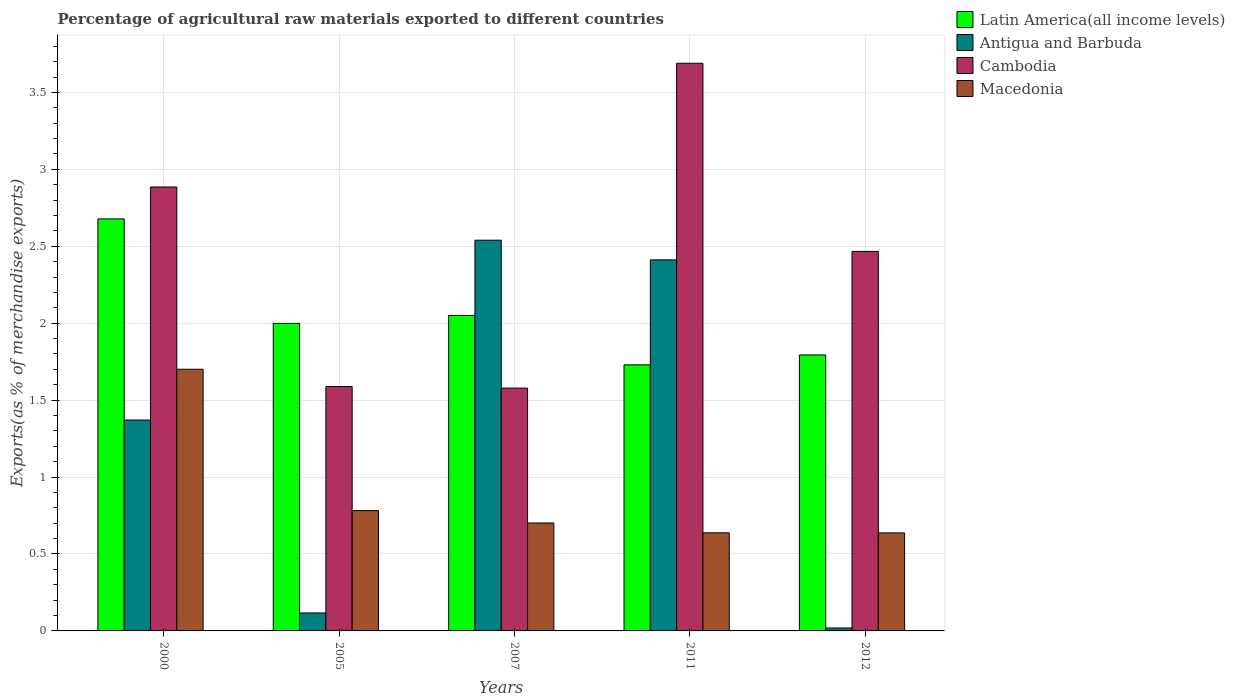How many different coloured bars are there?
Provide a succinct answer. 4. How many groups of bars are there?
Give a very brief answer. 5. Are the number of bars on each tick of the X-axis equal?
Offer a very short reply. Yes. How many bars are there on the 3rd tick from the right?
Ensure brevity in your answer.  4. What is the label of the 2nd group of bars from the left?
Ensure brevity in your answer.  2005. What is the percentage of exports to different countries in Antigua and Barbuda in 2000?
Your response must be concise. 1.37. Across all years, what is the maximum percentage of exports to different countries in Cambodia?
Make the answer very short. 3.69. Across all years, what is the minimum percentage of exports to different countries in Antigua and Barbuda?
Offer a terse response. 0.02. In which year was the percentage of exports to different countries in Macedonia minimum?
Offer a very short reply. 2012. What is the total percentage of exports to different countries in Latin America(all income levels) in the graph?
Your answer should be very brief. 10.25. What is the difference between the percentage of exports to different countries in Antigua and Barbuda in 2000 and that in 2007?
Ensure brevity in your answer.  -1.17. What is the difference between the percentage of exports to different countries in Cambodia in 2011 and the percentage of exports to different countries in Macedonia in 2000?
Offer a terse response. 1.99. What is the average percentage of exports to different countries in Cambodia per year?
Make the answer very short. 2.44. In the year 2005, what is the difference between the percentage of exports to different countries in Latin America(all income levels) and percentage of exports to different countries in Cambodia?
Make the answer very short. 0.41. What is the ratio of the percentage of exports to different countries in Antigua and Barbuda in 2007 to that in 2012?
Your response must be concise. 132.37. Is the difference between the percentage of exports to different countries in Latin America(all income levels) in 2000 and 2012 greater than the difference between the percentage of exports to different countries in Cambodia in 2000 and 2012?
Offer a very short reply. Yes. What is the difference between the highest and the second highest percentage of exports to different countries in Cambodia?
Offer a very short reply. 0.8. What is the difference between the highest and the lowest percentage of exports to different countries in Antigua and Barbuda?
Offer a terse response. 2.52. Is the sum of the percentage of exports to different countries in Antigua and Barbuda in 2005 and 2012 greater than the maximum percentage of exports to different countries in Latin America(all income levels) across all years?
Make the answer very short. No. Is it the case that in every year, the sum of the percentage of exports to different countries in Cambodia and percentage of exports to different countries in Macedonia is greater than the sum of percentage of exports to different countries in Antigua and Barbuda and percentage of exports to different countries in Latin America(all income levels)?
Give a very brief answer. No. What does the 3rd bar from the left in 2000 represents?
Give a very brief answer. Cambodia. What does the 3rd bar from the right in 2000 represents?
Give a very brief answer. Antigua and Barbuda. How many years are there in the graph?
Ensure brevity in your answer.  5. What is the difference between two consecutive major ticks on the Y-axis?
Your answer should be compact. 0.5. Are the values on the major ticks of Y-axis written in scientific E-notation?
Your response must be concise. No. Does the graph contain any zero values?
Provide a short and direct response. No. Does the graph contain grids?
Provide a short and direct response. Yes. What is the title of the graph?
Make the answer very short. Percentage of agricultural raw materials exported to different countries. What is the label or title of the X-axis?
Keep it short and to the point. Years. What is the label or title of the Y-axis?
Offer a terse response. Exports(as % of merchandise exports). What is the Exports(as % of merchandise exports) in Latin America(all income levels) in 2000?
Offer a very short reply. 2.68. What is the Exports(as % of merchandise exports) in Antigua and Barbuda in 2000?
Provide a succinct answer. 1.37. What is the Exports(as % of merchandise exports) in Cambodia in 2000?
Provide a short and direct response. 2.89. What is the Exports(as % of merchandise exports) of Macedonia in 2000?
Your answer should be compact. 1.7. What is the Exports(as % of merchandise exports) in Latin America(all income levels) in 2005?
Make the answer very short. 2. What is the Exports(as % of merchandise exports) in Antigua and Barbuda in 2005?
Offer a very short reply. 0.12. What is the Exports(as % of merchandise exports) in Cambodia in 2005?
Keep it short and to the point. 1.59. What is the Exports(as % of merchandise exports) in Macedonia in 2005?
Your answer should be compact. 0.78. What is the Exports(as % of merchandise exports) in Latin America(all income levels) in 2007?
Offer a terse response. 2.05. What is the Exports(as % of merchandise exports) of Antigua and Barbuda in 2007?
Offer a terse response. 2.54. What is the Exports(as % of merchandise exports) in Cambodia in 2007?
Provide a short and direct response. 1.58. What is the Exports(as % of merchandise exports) of Macedonia in 2007?
Give a very brief answer. 0.7. What is the Exports(as % of merchandise exports) of Latin America(all income levels) in 2011?
Give a very brief answer. 1.73. What is the Exports(as % of merchandise exports) in Antigua and Barbuda in 2011?
Your answer should be compact. 2.41. What is the Exports(as % of merchandise exports) of Cambodia in 2011?
Provide a short and direct response. 3.69. What is the Exports(as % of merchandise exports) of Macedonia in 2011?
Keep it short and to the point. 0.64. What is the Exports(as % of merchandise exports) in Latin America(all income levels) in 2012?
Keep it short and to the point. 1.79. What is the Exports(as % of merchandise exports) of Antigua and Barbuda in 2012?
Your response must be concise. 0.02. What is the Exports(as % of merchandise exports) of Cambodia in 2012?
Your response must be concise. 2.47. What is the Exports(as % of merchandise exports) of Macedonia in 2012?
Provide a short and direct response. 0.64. Across all years, what is the maximum Exports(as % of merchandise exports) of Latin America(all income levels)?
Ensure brevity in your answer.  2.68. Across all years, what is the maximum Exports(as % of merchandise exports) in Antigua and Barbuda?
Give a very brief answer. 2.54. Across all years, what is the maximum Exports(as % of merchandise exports) of Cambodia?
Offer a terse response. 3.69. Across all years, what is the maximum Exports(as % of merchandise exports) of Macedonia?
Give a very brief answer. 1.7. Across all years, what is the minimum Exports(as % of merchandise exports) of Latin America(all income levels)?
Keep it short and to the point. 1.73. Across all years, what is the minimum Exports(as % of merchandise exports) in Antigua and Barbuda?
Ensure brevity in your answer.  0.02. Across all years, what is the minimum Exports(as % of merchandise exports) of Cambodia?
Your answer should be very brief. 1.58. Across all years, what is the minimum Exports(as % of merchandise exports) of Macedonia?
Ensure brevity in your answer.  0.64. What is the total Exports(as % of merchandise exports) in Latin America(all income levels) in the graph?
Ensure brevity in your answer.  10.25. What is the total Exports(as % of merchandise exports) of Antigua and Barbuda in the graph?
Give a very brief answer. 6.46. What is the total Exports(as % of merchandise exports) of Cambodia in the graph?
Provide a succinct answer. 12.21. What is the total Exports(as % of merchandise exports) of Macedonia in the graph?
Offer a very short reply. 4.46. What is the difference between the Exports(as % of merchandise exports) in Latin America(all income levels) in 2000 and that in 2005?
Offer a terse response. 0.68. What is the difference between the Exports(as % of merchandise exports) of Antigua and Barbuda in 2000 and that in 2005?
Provide a succinct answer. 1.25. What is the difference between the Exports(as % of merchandise exports) of Cambodia in 2000 and that in 2005?
Your response must be concise. 1.3. What is the difference between the Exports(as % of merchandise exports) of Macedonia in 2000 and that in 2005?
Ensure brevity in your answer.  0.92. What is the difference between the Exports(as % of merchandise exports) in Latin America(all income levels) in 2000 and that in 2007?
Keep it short and to the point. 0.63. What is the difference between the Exports(as % of merchandise exports) of Antigua and Barbuda in 2000 and that in 2007?
Give a very brief answer. -1.17. What is the difference between the Exports(as % of merchandise exports) of Cambodia in 2000 and that in 2007?
Make the answer very short. 1.31. What is the difference between the Exports(as % of merchandise exports) of Macedonia in 2000 and that in 2007?
Offer a very short reply. 1. What is the difference between the Exports(as % of merchandise exports) of Latin America(all income levels) in 2000 and that in 2011?
Make the answer very short. 0.95. What is the difference between the Exports(as % of merchandise exports) in Antigua and Barbuda in 2000 and that in 2011?
Give a very brief answer. -1.04. What is the difference between the Exports(as % of merchandise exports) in Cambodia in 2000 and that in 2011?
Offer a terse response. -0.8. What is the difference between the Exports(as % of merchandise exports) in Macedonia in 2000 and that in 2011?
Your answer should be very brief. 1.06. What is the difference between the Exports(as % of merchandise exports) of Latin America(all income levels) in 2000 and that in 2012?
Your response must be concise. 0.88. What is the difference between the Exports(as % of merchandise exports) of Antigua and Barbuda in 2000 and that in 2012?
Provide a succinct answer. 1.35. What is the difference between the Exports(as % of merchandise exports) of Cambodia in 2000 and that in 2012?
Provide a succinct answer. 0.42. What is the difference between the Exports(as % of merchandise exports) of Macedonia in 2000 and that in 2012?
Keep it short and to the point. 1.06. What is the difference between the Exports(as % of merchandise exports) in Latin America(all income levels) in 2005 and that in 2007?
Your answer should be very brief. -0.05. What is the difference between the Exports(as % of merchandise exports) in Antigua and Barbuda in 2005 and that in 2007?
Provide a short and direct response. -2.42. What is the difference between the Exports(as % of merchandise exports) in Cambodia in 2005 and that in 2007?
Offer a very short reply. 0.01. What is the difference between the Exports(as % of merchandise exports) of Macedonia in 2005 and that in 2007?
Ensure brevity in your answer.  0.08. What is the difference between the Exports(as % of merchandise exports) in Latin America(all income levels) in 2005 and that in 2011?
Ensure brevity in your answer.  0.27. What is the difference between the Exports(as % of merchandise exports) of Antigua and Barbuda in 2005 and that in 2011?
Provide a short and direct response. -2.29. What is the difference between the Exports(as % of merchandise exports) in Cambodia in 2005 and that in 2011?
Make the answer very short. -2.1. What is the difference between the Exports(as % of merchandise exports) of Macedonia in 2005 and that in 2011?
Make the answer very short. 0.14. What is the difference between the Exports(as % of merchandise exports) of Latin America(all income levels) in 2005 and that in 2012?
Provide a short and direct response. 0.2. What is the difference between the Exports(as % of merchandise exports) of Antigua and Barbuda in 2005 and that in 2012?
Provide a short and direct response. 0.1. What is the difference between the Exports(as % of merchandise exports) in Cambodia in 2005 and that in 2012?
Ensure brevity in your answer.  -0.88. What is the difference between the Exports(as % of merchandise exports) of Macedonia in 2005 and that in 2012?
Provide a short and direct response. 0.14. What is the difference between the Exports(as % of merchandise exports) of Latin America(all income levels) in 2007 and that in 2011?
Your answer should be very brief. 0.32. What is the difference between the Exports(as % of merchandise exports) in Antigua and Barbuda in 2007 and that in 2011?
Your response must be concise. 0.13. What is the difference between the Exports(as % of merchandise exports) in Cambodia in 2007 and that in 2011?
Offer a terse response. -2.11. What is the difference between the Exports(as % of merchandise exports) of Macedonia in 2007 and that in 2011?
Provide a short and direct response. 0.06. What is the difference between the Exports(as % of merchandise exports) in Latin America(all income levels) in 2007 and that in 2012?
Give a very brief answer. 0.26. What is the difference between the Exports(as % of merchandise exports) in Antigua and Barbuda in 2007 and that in 2012?
Provide a succinct answer. 2.52. What is the difference between the Exports(as % of merchandise exports) of Cambodia in 2007 and that in 2012?
Give a very brief answer. -0.89. What is the difference between the Exports(as % of merchandise exports) of Macedonia in 2007 and that in 2012?
Your response must be concise. 0.06. What is the difference between the Exports(as % of merchandise exports) in Latin America(all income levels) in 2011 and that in 2012?
Your answer should be very brief. -0.06. What is the difference between the Exports(as % of merchandise exports) in Antigua and Barbuda in 2011 and that in 2012?
Your answer should be very brief. 2.39. What is the difference between the Exports(as % of merchandise exports) in Cambodia in 2011 and that in 2012?
Offer a very short reply. 1.22. What is the difference between the Exports(as % of merchandise exports) in Latin America(all income levels) in 2000 and the Exports(as % of merchandise exports) in Antigua and Barbuda in 2005?
Give a very brief answer. 2.56. What is the difference between the Exports(as % of merchandise exports) of Latin America(all income levels) in 2000 and the Exports(as % of merchandise exports) of Cambodia in 2005?
Provide a short and direct response. 1.09. What is the difference between the Exports(as % of merchandise exports) in Latin America(all income levels) in 2000 and the Exports(as % of merchandise exports) in Macedonia in 2005?
Provide a succinct answer. 1.9. What is the difference between the Exports(as % of merchandise exports) of Antigua and Barbuda in 2000 and the Exports(as % of merchandise exports) of Cambodia in 2005?
Give a very brief answer. -0.22. What is the difference between the Exports(as % of merchandise exports) in Antigua and Barbuda in 2000 and the Exports(as % of merchandise exports) in Macedonia in 2005?
Your answer should be compact. 0.59. What is the difference between the Exports(as % of merchandise exports) in Cambodia in 2000 and the Exports(as % of merchandise exports) in Macedonia in 2005?
Your response must be concise. 2.1. What is the difference between the Exports(as % of merchandise exports) of Latin America(all income levels) in 2000 and the Exports(as % of merchandise exports) of Antigua and Barbuda in 2007?
Make the answer very short. 0.14. What is the difference between the Exports(as % of merchandise exports) in Latin America(all income levels) in 2000 and the Exports(as % of merchandise exports) in Cambodia in 2007?
Ensure brevity in your answer.  1.1. What is the difference between the Exports(as % of merchandise exports) of Latin America(all income levels) in 2000 and the Exports(as % of merchandise exports) of Macedonia in 2007?
Offer a very short reply. 1.98. What is the difference between the Exports(as % of merchandise exports) in Antigua and Barbuda in 2000 and the Exports(as % of merchandise exports) in Cambodia in 2007?
Provide a succinct answer. -0.21. What is the difference between the Exports(as % of merchandise exports) in Antigua and Barbuda in 2000 and the Exports(as % of merchandise exports) in Macedonia in 2007?
Your response must be concise. 0.67. What is the difference between the Exports(as % of merchandise exports) in Cambodia in 2000 and the Exports(as % of merchandise exports) in Macedonia in 2007?
Offer a terse response. 2.18. What is the difference between the Exports(as % of merchandise exports) in Latin America(all income levels) in 2000 and the Exports(as % of merchandise exports) in Antigua and Barbuda in 2011?
Make the answer very short. 0.27. What is the difference between the Exports(as % of merchandise exports) of Latin America(all income levels) in 2000 and the Exports(as % of merchandise exports) of Cambodia in 2011?
Your answer should be compact. -1.01. What is the difference between the Exports(as % of merchandise exports) in Latin America(all income levels) in 2000 and the Exports(as % of merchandise exports) in Macedonia in 2011?
Your answer should be compact. 2.04. What is the difference between the Exports(as % of merchandise exports) of Antigua and Barbuda in 2000 and the Exports(as % of merchandise exports) of Cambodia in 2011?
Provide a short and direct response. -2.32. What is the difference between the Exports(as % of merchandise exports) in Antigua and Barbuda in 2000 and the Exports(as % of merchandise exports) in Macedonia in 2011?
Make the answer very short. 0.73. What is the difference between the Exports(as % of merchandise exports) of Cambodia in 2000 and the Exports(as % of merchandise exports) of Macedonia in 2011?
Your response must be concise. 2.25. What is the difference between the Exports(as % of merchandise exports) in Latin America(all income levels) in 2000 and the Exports(as % of merchandise exports) in Antigua and Barbuda in 2012?
Your answer should be compact. 2.66. What is the difference between the Exports(as % of merchandise exports) in Latin America(all income levels) in 2000 and the Exports(as % of merchandise exports) in Cambodia in 2012?
Provide a succinct answer. 0.21. What is the difference between the Exports(as % of merchandise exports) in Latin America(all income levels) in 2000 and the Exports(as % of merchandise exports) in Macedonia in 2012?
Ensure brevity in your answer.  2.04. What is the difference between the Exports(as % of merchandise exports) in Antigua and Barbuda in 2000 and the Exports(as % of merchandise exports) in Cambodia in 2012?
Give a very brief answer. -1.1. What is the difference between the Exports(as % of merchandise exports) of Antigua and Barbuda in 2000 and the Exports(as % of merchandise exports) of Macedonia in 2012?
Your answer should be compact. 0.73. What is the difference between the Exports(as % of merchandise exports) of Cambodia in 2000 and the Exports(as % of merchandise exports) of Macedonia in 2012?
Offer a terse response. 2.25. What is the difference between the Exports(as % of merchandise exports) in Latin America(all income levels) in 2005 and the Exports(as % of merchandise exports) in Antigua and Barbuda in 2007?
Make the answer very short. -0.54. What is the difference between the Exports(as % of merchandise exports) in Latin America(all income levels) in 2005 and the Exports(as % of merchandise exports) in Cambodia in 2007?
Give a very brief answer. 0.42. What is the difference between the Exports(as % of merchandise exports) of Latin America(all income levels) in 2005 and the Exports(as % of merchandise exports) of Macedonia in 2007?
Offer a very short reply. 1.3. What is the difference between the Exports(as % of merchandise exports) of Antigua and Barbuda in 2005 and the Exports(as % of merchandise exports) of Cambodia in 2007?
Your answer should be compact. -1.46. What is the difference between the Exports(as % of merchandise exports) in Antigua and Barbuda in 2005 and the Exports(as % of merchandise exports) in Macedonia in 2007?
Offer a terse response. -0.58. What is the difference between the Exports(as % of merchandise exports) of Cambodia in 2005 and the Exports(as % of merchandise exports) of Macedonia in 2007?
Your response must be concise. 0.89. What is the difference between the Exports(as % of merchandise exports) in Latin America(all income levels) in 2005 and the Exports(as % of merchandise exports) in Antigua and Barbuda in 2011?
Offer a very short reply. -0.41. What is the difference between the Exports(as % of merchandise exports) of Latin America(all income levels) in 2005 and the Exports(as % of merchandise exports) of Cambodia in 2011?
Make the answer very short. -1.69. What is the difference between the Exports(as % of merchandise exports) in Latin America(all income levels) in 2005 and the Exports(as % of merchandise exports) in Macedonia in 2011?
Keep it short and to the point. 1.36. What is the difference between the Exports(as % of merchandise exports) of Antigua and Barbuda in 2005 and the Exports(as % of merchandise exports) of Cambodia in 2011?
Give a very brief answer. -3.57. What is the difference between the Exports(as % of merchandise exports) in Antigua and Barbuda in 2005 and the Exports(as % of merchandise exports) in Macedonia in 2011?
Give a very brief answer. -0.52. What is the difference between the Exports(as % of merchandise exports) in Cambodia in 2005 and the Exports(as % of merchandise exports) in Macedonia in 2011?
Make the answer very short. 0.95. What is the difference between the Exports(as % of merchandise exports) of Latin America(all income levels) in 2005 and the Exports(as % of merchandise exports) of Antigua and Barbuda in 2012?
Offer a terse response. 1.98. What is the difference between the Exports(as % of merchandise exports) of Latin America(all income levels) in 2005 and the Exports(as % of merchandise exports) of Cambodia in 2012?
Your response must be concise. -0.47. What is the difference between the Exports(as % of merchandise exports) in Latin America(all income levels) in 2005 and the Exports(as % of merchandise exports) in Macedonia in 2012?
Offer a terse response. 1.36. What is the difference between the Exports(as % of merchandise exports) of Antigua and Barbuda in 2005 and the Exports(as % of merchandise exports) of Cambodia in 2012?
Offer a very short reply. -2.35. What is the difference between the Exports(as % of merchandise exports) of Antigua and Barbuda in 2005 and the Exports(as % of merchandise exports) of Macedonia in 2012?
Offer a terse response. -0.52. What is the difference between the Exports(as % of merchandise exports) of Cambodia in 2005 and the Exports(as % of merchandise exports) of Macedonia in 2012?
Provide a succinct answer. 0.95. What is the difference between the Exports(as % of merchandise exports) in Latin America(all income levels) in 2007 and the Exports(as % of merchandise exports) in Antigua and Barbuda in 2011?
Your response must be concise. -0.36. What is the difference between the Exports(as % of merchandise exports) in Latin America(all income levels) in 2007 and the Exports(as % of merchandise exports) in Cambodia in 2011?
Provide a succinct answer. -1.64. What is the difference between the Exports(as % of merchandise exports) in Latin America(all income levels) in 2007 and the Exports(as % of merchandise exports) in Macedonia in 2011?
Your answer should be very brief. 1.41. What is the difference between the Exports(as % of merchandise exports) in Antigua and Barbuda in 2007 and the Exports(as % of merchandise exports) in Cambodia in 2011?
Your response must be concise. -1.15. What is the difference between the Exports(as % of merchandise exports) in Antigua and Barbuda in 2007 and the Exports(as % of merchandise exports) in Macedonia in 2011?
Ensure brevity in your answer.  1.9. What is the difference between the Exports(as % of merchandise exports) of Cambodia in 2007 and the Exports(as % of merchandise exports) of Macedonia in 2011?
Your answer should be very brief. 0.94. What is the difference between the Exports(as % of merchandise exports) of Latin America(all income levels) in 2007 and the Exports(as % of merchandise exports) of Antigua and Barbuda in 2012?
Your response must be concise. 2.03. What is the difference between the Exports(as % of merchandise exports) of Latin America(all income levels) in 2007 and the Exports(as % of merchandise exports) of Cambodia in 2012?
Provide a short and direct response. -0.42. What is the difference between the Exports(as % of merchandise exports) of Latin America(all income levels) in 2007 and the Exports(as % of merchandise exports) of Macedonia in 2012?
Your response must be concise. 1.41. What is the difference between the Exports(as % of merchandise exports) of Antigua and Barbuda in 2007 and the Exports(as % of merchandise exports) of Cambodia in 2012?
Provide a succinct answer. 0.07. What is the difference between the Exports(as % of merchandise exports) of Antigua and Barbuda in 2007 and the Exports(as % of merchandise exports) of Macedonia in 2012?
Your answer should be compact. 1.9. What is the difference between the Exports(as % of merchandise exports) of Cambodia in 2007 and the Exports(as % of merchandise exports) of Macedonia in 2012?
Keep it short and to the point. 0.94. What is the difference between the Exports(as % of merchandise exports) in Latin America(all income levels) in 2011 and the Exports(as % of merchandise exports) in Antigua and Barbuda in 2012?
Your answer should be very brief. 1.71. What is the difference between the Exports(as % of merchandise exports) of Latin America(all income levels) in 2011 and the Exports(as % of merchandise exports) of Cambodia in 2012?
Provide a succinct answer. -0.74. What is the difference between the Exports(as % of merchandise exports) of Latin America(all income levels) in 2011 and the Exports(as % of merchandise exports) of Macedonia in 2012?
Offer a very short reply. 1.09. What is the difference between the Exports(as % of merchandise exports) of Antigua and Barbuda in 2011 and the Exports(as % of merchandise exports) of Cambodia in 2012?
Offer a terse response. -0.06. What is the difference between the Exports(as % of merchandise exports) of Antigua and Barbuda in 2011 and the Exports(as % of merchandise exports) of Macedonia in 2012?
Provide a short and direct response. 1.77. What is the difference between the Exports(as % of merchandise exports) in Cambodia in 2011 and the Exports(as % of merchandise exports) in Macedonia in 2012?
Offer a terse response. 3.05. What is the average Exports(as % of merchandise exports) of Latin America(all income levels) per year?
Give a very brief answer. 2.05. What is the average Exports(as % of merchandise exports) of Antigua and Barbuda per year?
Offer a very short reply. 1.29. What is the average Exports(as % of merchandise exports) in Cambodia per year?
Offer a terse response. 2.44. What is the average Exports(as % of merchandise exports) in Macedonia per year?
Ensure brevity in your answer.  0.89. In the year 2000, what is the difference between the Exports(as % of merchandise exports) of Latin America(all income levels) and Exports(as % of merchandise exports) of Antigua and Barbuda?
Give a very brief answer. 1.31. In the year 2000, what is the difference between the Exports(as % of merchandise exports) of Latin America(all income levels) and Exports(as % of merchandise exports) of Cambodia?
Provide a short and direct response. -0.21. In the year 2000, what is the difference between the Exports(as % of merchandise exports) of Latin America(all income levels) and Exports(as % of merchandise exports) of Macedonia?
Offer a terse response. 0.98. In the year 2000, what is the difference between the Exports(as % of merchandise exports) of Antigua and Barbuda and Exports(as % of merchandise exports) of Cambodia?
Offer a very short reply. -1.51. In the year 2000, what is the difference between the Exports(as % of merchandise exports) of Antigua and Barbuda and Exports(as % of merchandise exports) of Macedonia?
Your answer should be very brief. -0.33. In the year 2000, what is the difference between the Exports(as % of merchandise exports) in Cambodia and Exports(as % of merchandise exports) in Macedonia?
Provide a succinct answer. 1.18. In the year 2005, what is the difference between the Exports(as % of merchandise exports) of Latin America(all income levels) and Exports(as % of merchandise exports) of Antigua and Barbuda?
Keep it short and to the point. 1.88. In the year 2005, what is the difference between the Exports(as % of merchandise exports) of Latin America(all income levels) and Exports(as % of merchandise exports) of Cambodia?
Your answer should be compact. 0.41. In the year 2005, what is the difference between the Exports(as % of merchandise exports) in Latin America(all income levels) and Exports(as % of merchandise exports) in Macedonia?
Keep it short and to the point. 1.22. In the year 2005, what is the difference between the Exports(as % of merchandise exports) of Antigua and Barbuda and Exports(as % of merchandise exports) of Cambodia?
Provide a short and direct response. -1.47. In the year 2005, what is the difference between the Exports(as % of merchandise exports) of Antigua and Barbuda and Exports(as % of merchandise exports) of Macedonia?
Offer a very short reply. -0.67. In the year 2005, what is the difference between the Exports(as % of merchandise exports) in Cambodia and Exports(as % of merchandise exports) in Macedonia?
Provide a short and direct response. 0.81. In the year 2007, what is the difference between the Exports(as % of merchandise exports) of Latin America(all income levels) and Exports(as % of merchandise exports) of Antigua and Barbuda?
Ensure brevity in your answer.  -0.49. In the year 2007, what is the difference between the Exports(as % of merchandise exports) of Latin America(all income levels) and Exports(as % of merchandise exports) of Cambodia?
Keep it short and to the point. 0.47. In the year 2007, what is the difference between the Exports(as % of merchandise exports) of Latin America(all income levels) and Exports(as % of merchandise exports) of Macedonia?
Provide a short and direct response. 1.35. In the year 2007, what is the difference between the Exports(as % of merchandise exports) of Antigua and Barbuda and Exports(as % of merchandise exports) of Cambodia?
Ensure brevity in your answer.  0.96. In the year 2007, what is the difference between the Exports(as % of merchandise exports) of Antigua and Barbuda and Exports(as % of merchandise exports) of Macedonia?
Your response must be concise. 1.84. In the year 2007, what is the difference between the Exports(as % of merchandise exports) in Cambodia and Exports(as % of merchandise exports) in Macedonia?
Provide a succinct answer. 0.88. In the year 2011, what is the difference between the Exports(as % of merchandise exports) of Latin America(all income levels) and Exports(as % of merchandise exports) of Antigua and Barbuda?
Provide a succinct answer. -0.68. In the year 2011, what is the difference between the Exports(as % of merchandise exports) of Latin America(all income levels) and Exports(as % of merchandise exports) of Cambodia?
Provide a succinct answer. -1.96. In the year 2011, what is the difference between the Exports(as % of merchandise exports) in Latin America(all income levels) and Exports(as % of merchandise exports) in Macedonia?
Offer a terse response. 1.09. In the year 2011, what is the difference between the Exports(as % of merchandise exports) in Antigua and Barbuda and Exports(as % of merchandise exports) in Cambodia?
Keep it short and to the point. -1.28. In the year 2011, what is the difference between the Exports(as % of merchandise exports) in Antigua and Barbuda and Exports(as % of merchandise exports) in Macedonia?
Make the answer very short. 1.77. In the year 2011, what is the difference between the Exports(as % of merchandise exports) of Cambodia and Exports(as % of merchandise exports) of Macedonia?
Make the answer very short. 3.05. In the year 2012, what is the difference between the Exports(as % of merchandise exports) in Latin America(all income levels) and Exports(as % of merchandise exports) in Antigua and Barbuda?
Give a very brief answer. 1.77. In the year 2012, what is the difference between the Exports(as % of merchandise exports) in Latin America(all income levels) and Exports(as % of merchandise exports) in Cambodia?
Offer a very short reply. -0.67. In the year 2012, what is the difference between the Exports(as % of merchandise exports) of Latin America(all income levels) and Exports(as % of merchandise exports) of Macedonia?
Ensure brevity in your answer.  1.16. In the year 2012, what is the difference between the Exports(as % of merchandise exports) in Antigua and Barbuda and Exports(as % of merchandise exports) in Cambodia?
Provide a succinct answer. -2.45. In the year 2012, what is the difference between the Exports(as % of merchandise exports) of Antigua and Barbuda and Exports(as % of merchandise exports) of Macedonia?
Your answer should be very brief. -0.62. In the year 2012, what is the difference between the Exports(as % of merchandise exports) in Cambodia and Exports(as % of merchandise exports) in Macedonia?
Your answer should be compact. 1.83. What is the ratio of the Exports(as % of merchandise exports) of Latin America(all income levels) in 2000 to that in 2005?
Provide a succinct answer. 1.34. What is the ratio of the Exports(as % of merchandise exports) of Antigua and Barbuda in 2000 to that in 2005?
Offer a very short reply. 11.74. What is the ratio of the Exports(as % of merchandise exports) of Cambodia in 2000 to that in 2005?
Offer a terse response. 1.82. What is the ratio of the Exports(as % of merchandise exports) of Macedonia in 2000 to that in 2005?
Your answer should be very brief. 2.18. What is the ratio of the Exports(as % of merchandise exports) in Latin America(all income levels) in 2000 to that in 2007?
Offer a very short reply. 1.31. What is the ratio of the Exports(as % of merchandise exports) in Antigua and Barbuda in 2000 to that in 2007?
Give a very brief answer. 0.54. What is the ratio of the Exports(as % of merchandise exports) of Cambodia in 2000 to that in 2007?
Your answer should be compact. 1.83. What is the ratio of the Exports(as % of merchandise exports) in Macedonia in 2000 to that in 2007?
Make the answer very short. 2.42. What is the ratio of the Exports(as % of merchandise exports) in Latin America(all income levels) in 2000 to that in 2011?
Your response must be concise. 1.55. What is the ratio of the Exports(as % of merchandise exports) in Antigua and Barbuda in 2000 to that in 2011?
Keep it short and to the point. 0.57. What is the ratio of the Exports(as % of merchandise exports) in Cambodia in 2000 to that in 2011?
Provide a succinct answer. 0.78. What is the ratio of the Exports(as % of merchandise exports) of Macedonia in 2000 to that in 2011?
Provide a short and direct response. 2.67. What is the ratio of the Exports(as % of merchandise exports) of Latin America(all income levels) in 2000 to that in 2012?
Your answer should be very brief. 1.49. What is the ratio of the Exports(as % of merchandise exports) in Antigua and Barbuda in 2000 to that in 2012?
Offer a very short reply. 71.44. What is the ratio of the Exports(as % of merchandise exports) in Cambodia in 2000 to that in 2012?
Your response must be concise. 1.17. What is the ratio of the Exports(as % of merchandise exports) of Macedonia in 2000 to that in 2012?
Provide a short and direct response. 2.67. What is the ratio of the Exports(as % of merchandise exports) in Latin America(all income levels) in 2005 to that in 2007?
Your response must be concise. 0.97. What is the ratio of the Exports(as % of merchandise exports) in Antigua and Barbuda in 2005 to that in 2007?
Offer a terse response. 0.05. What is the ratio of the Exports(as % of merchandise exports) in Cambodia in 2005 to that in 2007?
Your answer should be compact. 1.01. What is the ratio of the Exports(as % of merchandise exports) of Macedonia in 2005 to that in 2007?
Offer a terse response. 1.11. What is the ratio of the Exports(as % of merchandise exports) in Latin America(all income levels) in 2005 to that in 2011?
Your response must be concise. 1.16. What is the ratio of the Exports(as % of merchandise exports) in Antigua and Barbuda in 2005 to that in 2011?
Offer a very short reply. 0.05. What is the ratio of the Exports(as % of merchandise exports) in Cambodia in 2005 to that in 2011?
Your response must be concise. 0.43. What is the ratio of the Exports(as % of merchandise exports) of Macedonia in 2005 to that in 2011?
Your response must be concise. 1.23. What is the ratio of the Exports(as % of merchandise exports) in Latin America(all income levels) in 2005 to that in 2012?
Offer a very short reply. 1.11. What is the ratio of the Exports(as % of merchandise exports) in Antigua and Barbuda in 2005 to that in 2012?
Keep it short and to the point. 6.09. What is the ratio of the Exports(as % of merchandise exports) of Cambodia in 2005 to that in 2012?
Give a very brief answer. 0.64. What is the ratio of the Exports(as % of merchandise exports) in Macedonia in 2005 to that in 2012?
Make the answer very short. 1.23. What is the ratio of the Exports(as % of merchandise exports) in Latin America(all income levels) in 2007 to that in 2011?
Offer a terse response. 1.19. What is the ratio of the Exports(as % of merchandise exports) in Antigua and Barbuda in 2007 to that in 2011?
Give a very brief answer. 1.05. What is the ratio of the Exports(as % of merchandise exports) of Cambodia in 2007 to that in 2011?
Give a very brief answer. 0.43. What is the ratio of the Exports(as % of merchandise exports) in Macedonia in 2007 to that in 2011?
Your response must be concise. 1.1. What is the ratio of the Exports(as % of merchandise exports) of Latin America(all income levels) in 2007 to that in 2012?
Ensure brevity in your answer.  1.14. What is the ratio of the Exports(as % of merchandise exports) in Antigua and Barbuda in 2007 to that in 2012?
Your answer should be compact. 132.37. What is the ratio of the Exports(as % of merchandise exports) in Cambodia in 2007 to that in 2012?
Give a very brief answer. 0.64. What is the ratio of the Exports(as % of merchandise exports) in Macedonia in 2007 to that in 2012?
Ensure brevity in your answer.  1.1. What is the ratio of the Exports(as % of merchandise exports) of Latin America(all income levels) in 2011 to that in 2012?
Offer a terse response. 0.96. What is the ratio of the Exports(as % of merchandise exports) in Antigua and Barbuda in 2011 to that in 2012?
Offer a very short reply. 125.7. What is the ratio of the Exports(as % of merchandise exports) in Cambodia in 2011 to that in 2012?
Keep it short and to the point. 1.5. What is the ratio of the Exports(as % of merchandise exports) in Macedonia in 2011 to that in 2012?
Make the answer very short. 1. What is the difference between the highest and the second highest Exports(as % of merchandise exports) of Latin America(all income levels)?
Provide a succinct answer. 0.63. What is the difference between the highest and the second highest Exports(as % of merchandise exports) of Antigua and Barbuda?
Make the answer very short. 0.13. What is the difference between the highest and the second highest Exports(as % of merchandise exports) of Cambodia?
Your answer should be very brief. 0.8. What is the difference between the highest and the second highest Exports(as % of merchandise exports) in Macedonia?
Your answer should be compact. 0.92. What is the difference between the highest and the lowest Exports(as % of merchandise exports) of Latin America(all income levels)?
Your answer should be compact. 0.95. What is the difference between the highest and the lowest Exports(as % of merchandise exports) in Antigua and Barbuda?
Ensure brevity in your answer.  2.52. What is the difference between the highest and the lowest Exports(as % of merchandise exports) in Cambodia?
Make the answer very short. 2.11. What is the difference between the highest and the lowest Exports(as % of merchandise exports) in Macedonia?
Make the answer very short. 1.06. 